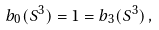<formula> <loc_0><loc_0><loc_500><loc_500>b _ { 0 } ( S ^ { 3 } ) = 1 = b _ { 3 } ( S ^ { 3 } ) \, ,</formula> 